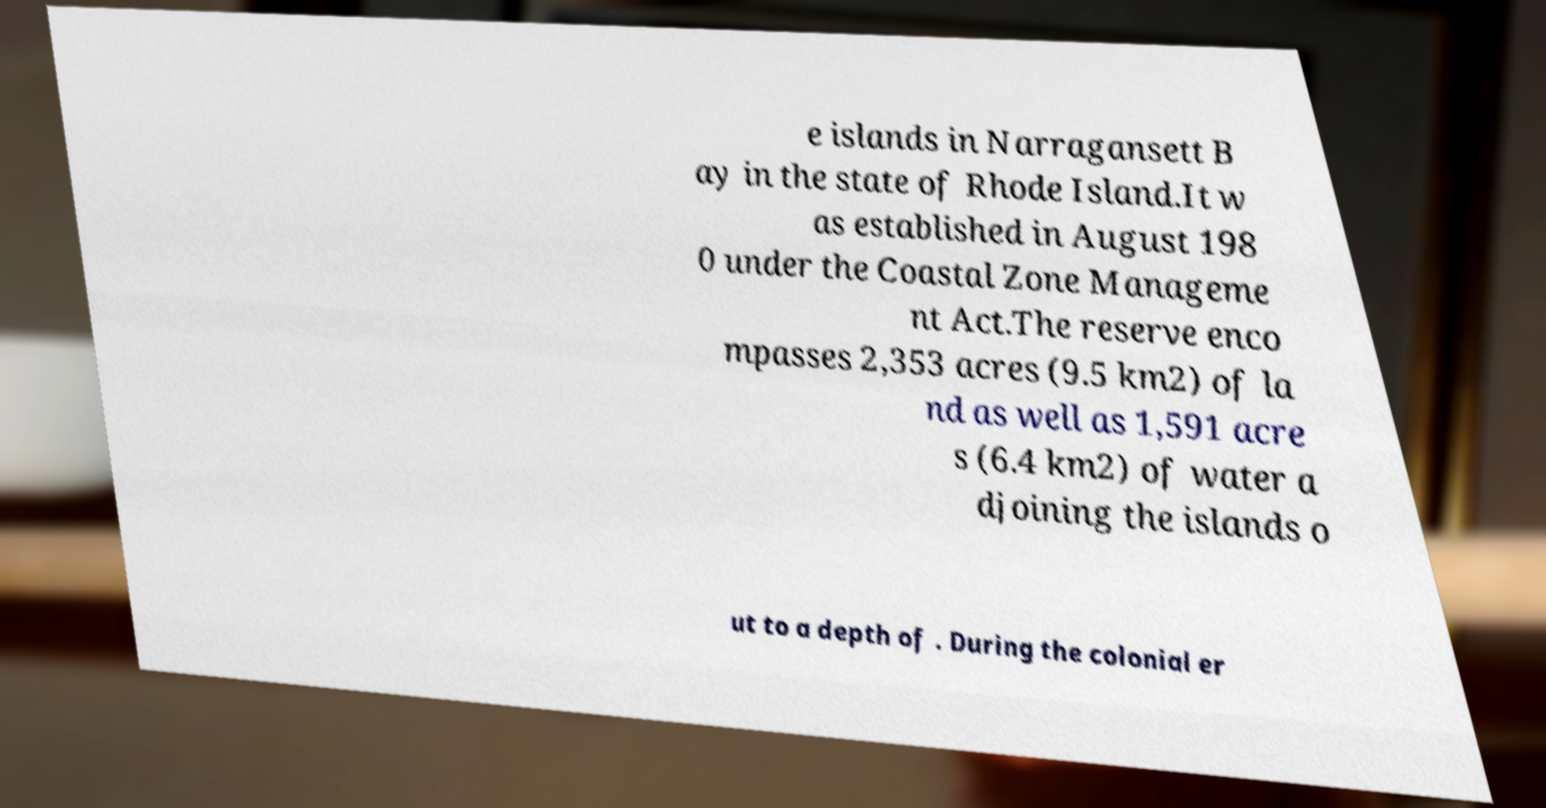Please identify and transcribe the text found in this image. e islands in Narragansett B ay in the state of Rhode Island.It w as established in August 198 0 under the Coastal Zone Manageme nt Act.The reserve enco mpasses 2,353 acres (9.5 km2) of la nd as well as 1,591 acre s (6.4 km2) of water a djoining the islands o ut to a depth of . During the colonial er 